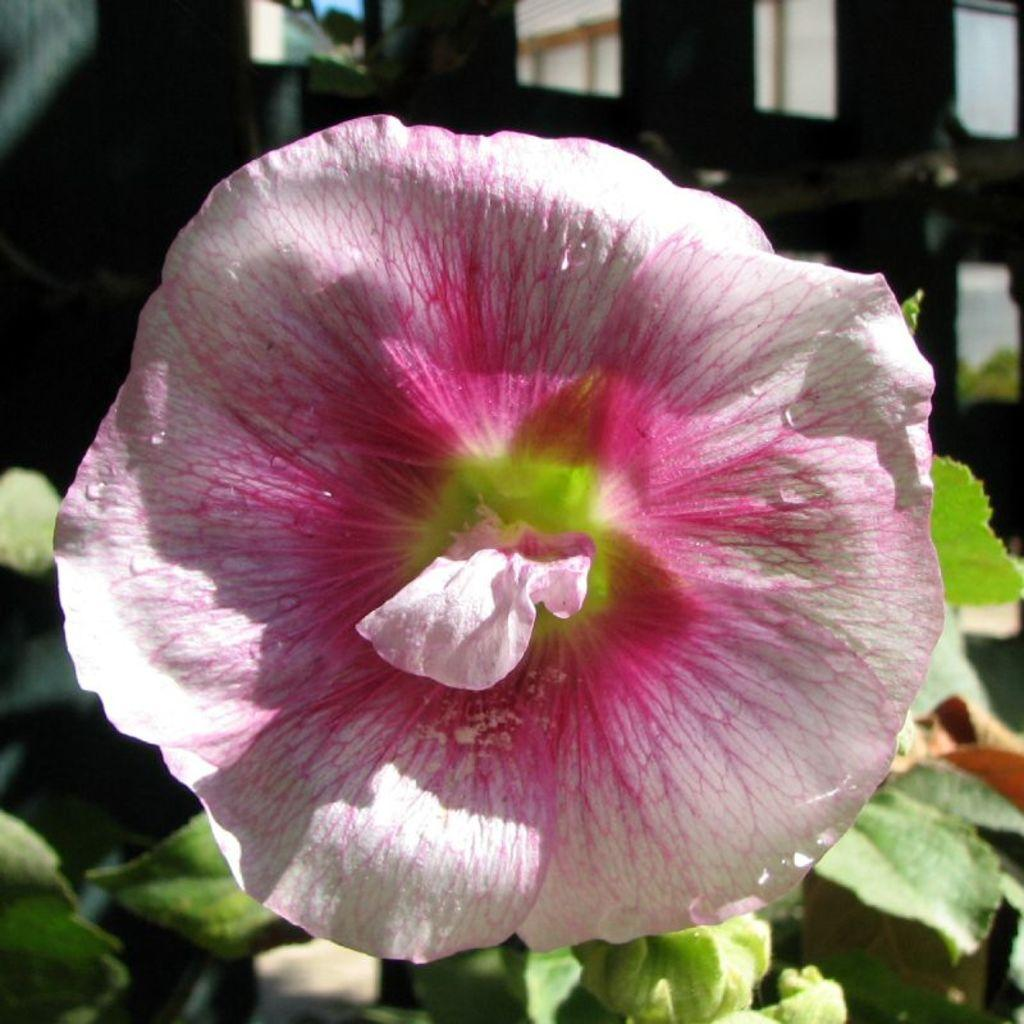What is the main subject in the center of the image? There is a flower in the center of the image. What can be seen in the background of the image? There are leaves and a building visible in the background of the image. What type of powder is being used to condition the flower in the image? There is no powder or conditioning process visible in the image; it simply features a flower with leaves and a building in the background. 